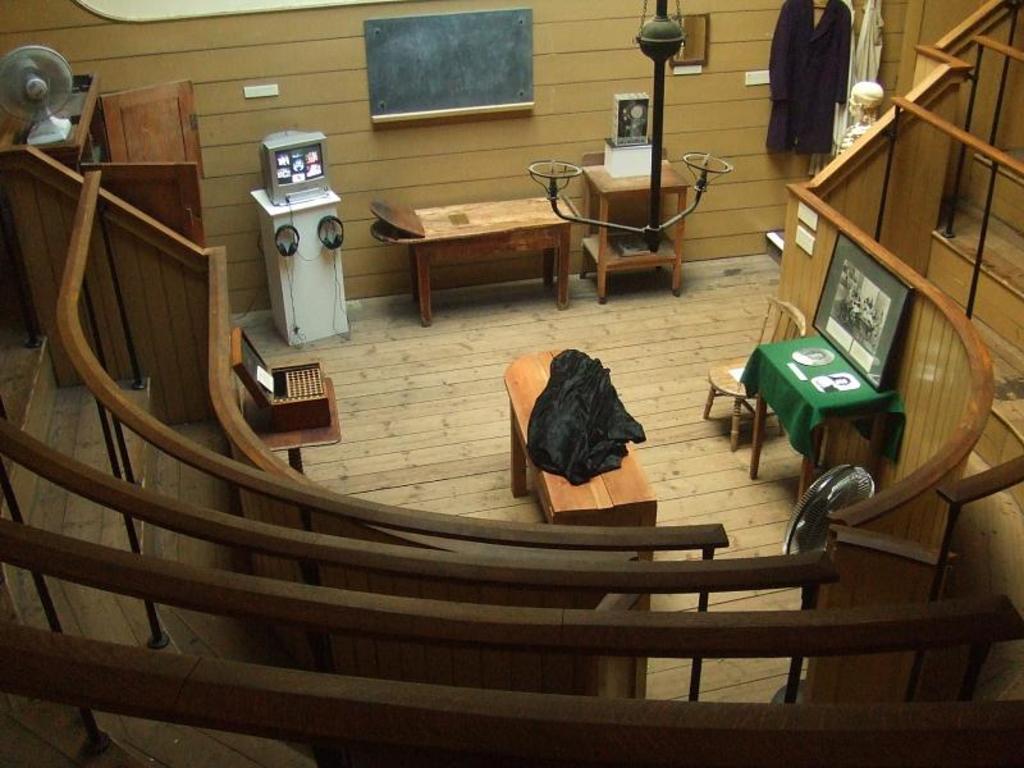In one or two sentences, can you explain what this image depicts? In this image I can see wooden tables, chairs, a photo frame on one table, television, headphones,wooden stairs,clothes, a cupboard, table fan and also there are some objects. 